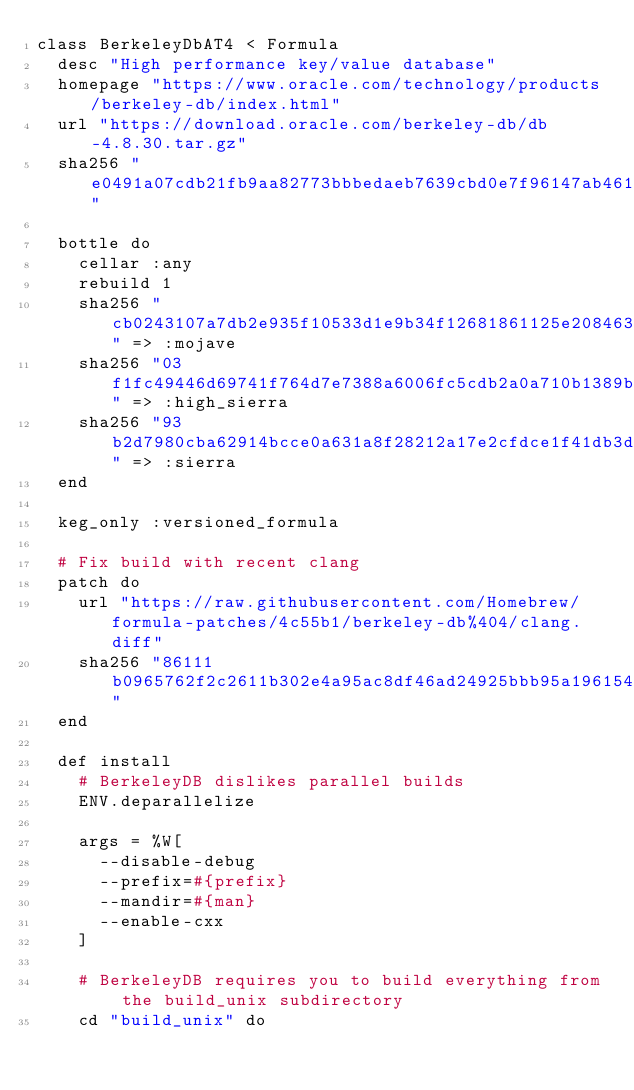<code> <loc_0><loc_0><loc_500><loc_500><_Ruby_>class BerkeleyDbAT4 < Formula
  desc "High performance key/value database"
  homepage "https://www.oracle.com/technology/products/berkeley-db/index.html"
  url "https://download.oracle.com/berkeley-db/db-4.8.30.tar.gz"
  sha256 "e0491a07cdb21fb9aa82773bbbedaeb7639cbd0e7f96147ab46141e0045db72a"

  bottle do
    cellar :any
    rebuild 1
    sha256 "cb0243107a7db2e935f10533d1e9b34f12681861125e208463b240572b86507d" => :mojave
    sha256 "03f1fc49446d69741f764d7e7388a6006fc5cdb2a0a710b1389b5b662b25e9b7" => :high_sierra
    sha256 "93b2d7980cba62914bcce0a631a8f28212a17e2cfdce1f41db3d47ec3da37fde" => :sierra
  end

  keg_only :versioned_formula

  # Fix build with recent clang
  patch do
    url "https://raw.githubusercontent.com/Homebrew/formula-patches/4c55b1/berkeley-db%404/clang.diff"
    sha256 "86111b0965762f2c2611b302e4a95ac8df46ad24925bbb95a1961542a1542e40"
  end

  def install
    # BerkeleyDB dislikes parallel builds
    ENV.deparallelize

    args = %W[
      --disable-debug
      --prefix=#{prefix}
      --mandir=#{man}
      --enable-cxx
    ]

    # BerkeleyDB requires you to build everything from the build_unix subdirectory
    cd "build_unix" do</code> 